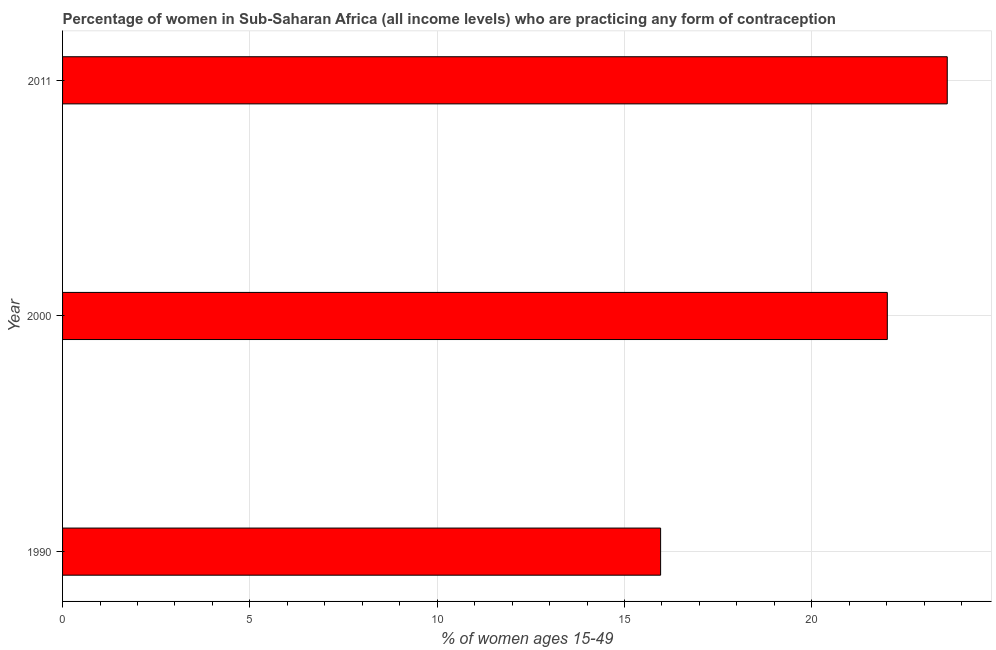Does the graph contain grids?
Provide a short and direct response. Yes. What is the title of the graph?
Provide a short and direct response. Percentage of women in Sub-Saharan Africa (all income levels) who are practicing any form of contraception. What is the label or title of the X-axis?
Provide a succinct answer. % of women ages 15-49. What is the label or title of the Y-axis?
Offer a very short reply. Year. What is the contraceptive prevalence in 2011?
Your answer should be very brief. 23.61. Across all years, what is the maximum contraceptive prevalence?
Ensure brevity in your answer.  23.61. Across all years, what is the minimum contraceptive prevalence?
Make the answer very short. 15.96. What is the sum of the contraceptive prevalence?
Offer a very short reply. 61.59. What is the difference between the contraceptive prevalence in 1990 and 2011?
Your response must be concise. -7.65. What is the average contraceptive prevalence per year?
Ensure brevity in your answer.  20.53. What is the median contraceptive prevalence?
Provide a succinct answer. 22.01. In how many years, is the contraceptive prevalence greater than 14 %?
Provide a succinct answer. 3. Do a majority of the years between 2000 and 2011 (inclusive) have contraceptive prevalence greater than 13 %?
Ensure brevity in your answer.  Yes. What is the ratio of the contraceptive prevalence in 1990 to that in 2011?
Your answer should be compact. 0.68. What is the difference between the highest and the second highest contraceptive prevalence?
Ensure brevity in your answer.  1.6. What is the difference between the highest and the lowest contraceptive prevalence?
Ensure brevity in your answer.  7.65. In how many years, is the contraceptive prevalence greater than the average contraceptive prevalence taken over all years?
Your answer should be very brief. 2. How many bars are there?
Provide a short and direct response. 3. What is the % of women ages 15-49 of 1990?
Your response must be concise. 15.96. What is the % of women ages 15-49 of 2000?
Make the answer very short. 22.01. What is the % of women ages 15-49 of 2011?
Provide a succinct answer. 23.61. What is the difference between the % of women ages 15-49 in 1990 and 2000?
Your answer should be very brief. -6.05. What is the difference between the % of women ages 15-49 in 1990 and 2011?
Keep it short and to the point. -7.65. What is the difference between the % of women ages 15-49 in 2000 and 2011?
Provide a succinct answer. -1.6. What is the ratio of the % of women ages 15-49 in 1990 to that in 2000?
Provide a short and direct response. 0.72. What is the ratio of the % of women ages 15-49 in 1990 to that in 2011?
Keep it short and to the point. 0.68. What is the ratio of the % of women ages 15-49 in 2000 to that in 2011?
Provide a short and direct response. 0.93. 